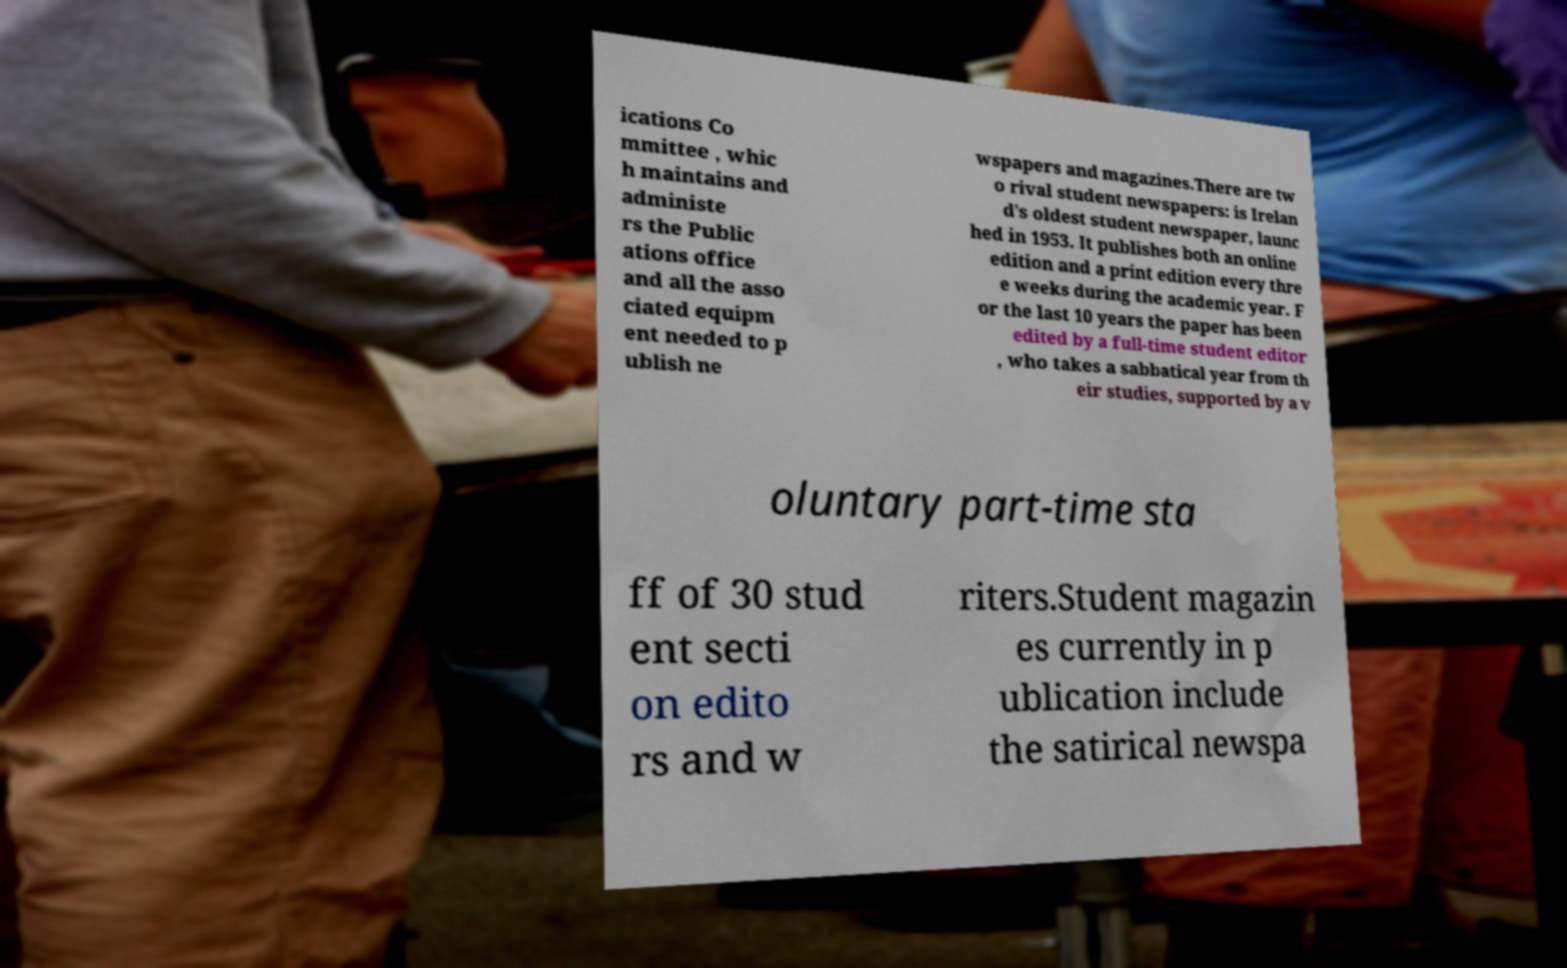Could you assist in decoding the text presented in this image and type it out clearly? ications Co mmittee , whic h maintains and administe rs the Public ations office and all the asso ciated equipm ent needed to p ublish ne wspapers and magazines.There are tw o rival student newspapers: is Irelan d's oldest student newspaper, launc hed in 1953. It publishes both an online edition and a print edition every thre e weeks during the academic year. F or the last 10 years the paper has been edited by a full-time student editor , who takes a sabbatical year from th eir studies, supported by a v oluntary part-time sta ff of 30 stud ent secti on edito rs and w riters.Student magazin es currently in p ublication include the satirical newspa 